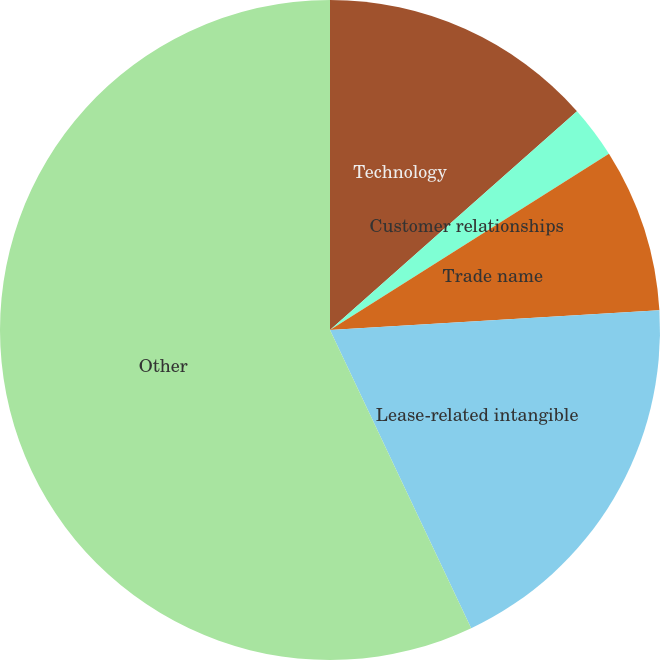Convert chart to OTSL. <chart><loc_0><loc_0><loc_500><loc_500><pie_chart><fcel>Technology<fcel>Customer relationships<fcel>Trade name<fcel>Lease-related intangible<fcel>Other<nl><fcel>13.46%<fcel>2.57%<fcel>8.02%<fcel>18.91%<fcel>57.03%<nl></chart> 